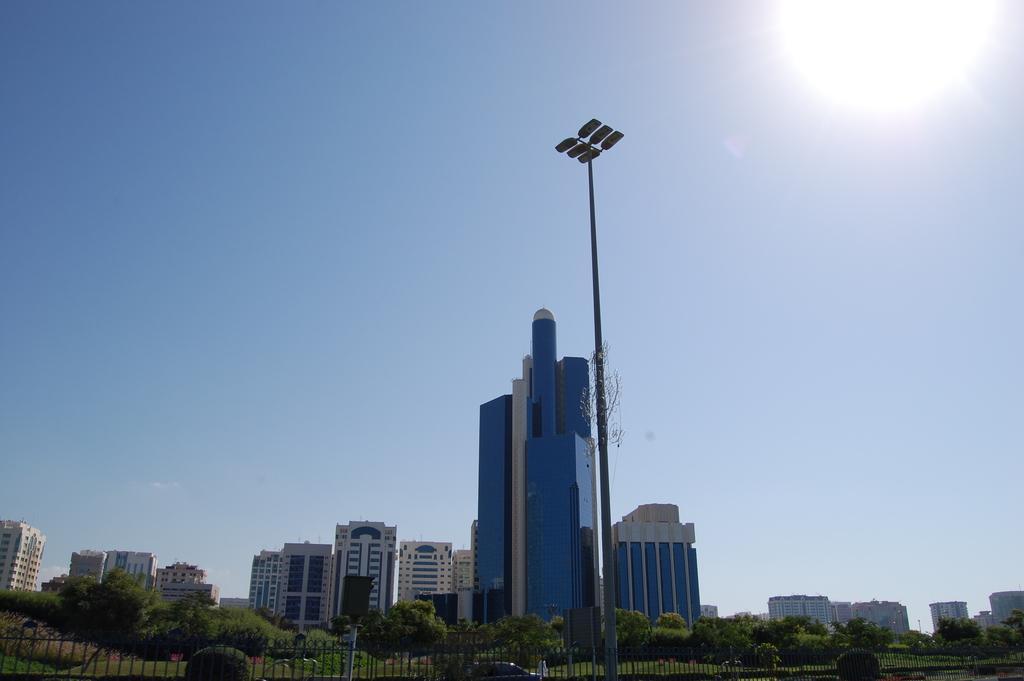Can you describe this image briefly? This image consists of many buildings. At the bottom, there are trees. And we can see a fencing. In the middle, there is a pole. At the top, there is sky. 